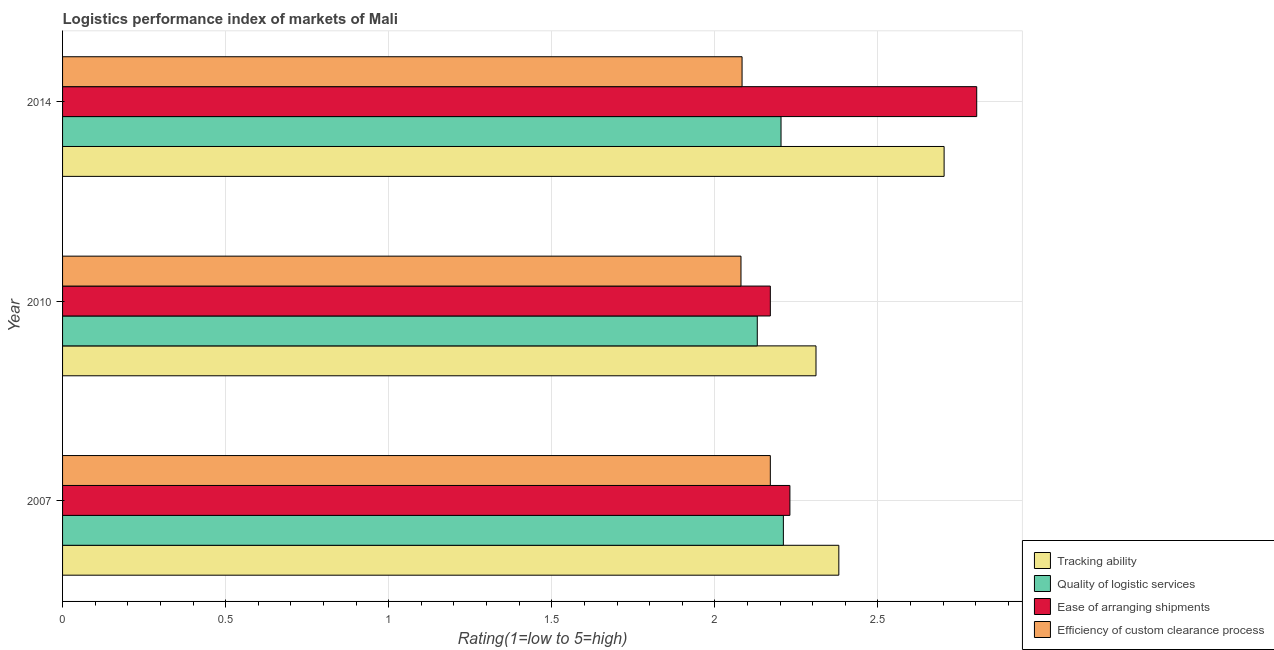How many different coloured bars are there?
Your answer should be compact. 4. How many groups of bars are there?
Offer a terse response. 3. How many bars are there on the 2nd tick from the bottom?
Keep it short and to the point. 4. In how many cases, is the number of bars for a given year not equal to the number of legend labels?
Offer a very short reply. 0. What is the lpi rating of quality of logistic services in 2010?
Your response must be concise. 2.13. Across all years, what is the maximum lpi rating of ease of arranging shipments?
Your answer should be compact. 2.8. Across all years, what is the minimum lpi rating of quality of logistic services?
Provide a succinct answer. 2.13. What is the total lpi rating of ease of arranging shipments in the graph?
Your answer should be compact. 7.2. What is the difference between the lpi rating of quality of logistic services in 2010 and that in 2014?
Provide a short and direct response. -0.07. What is the difference between the lpi rating of ease of arranging shipments in 2010 and the lpi rating of efficiency of custom clearance process in 2007?
Keep it short and to the point. 0. What is the average lpi rating of ease of arranging shipments per year?
Your answer should be compact. 2.4. In the year 2010, what is the difference between the lpi rating of efficiency of custom clearance process and lpi rating of tracking ability?
Offer a terse response. -0.23. In how many years, is the lpi rating of tracking ability greater than 1.7 ?
Your answer should be very brief. 3. What is the ratio of the lpi rating of ease of arranging shipments in 2007 to that in 2010?
Ensure brevity in your answer.  1.03. Is the lpi rating of efficiency of custom clearance process in 2007 less than that in 2014?
Offer a very short reply. No. What is the difference between the highest and the second highest lpi rating of tracking ability?
Your answer should be compact. 0.32. What is the difference between the highest and the lowest lpi rating of efficiency of custom clearance process?
Give a very brief answer. 0.09. In how many years, is the lpi rating of tracking ability greater than the average lpi rating of tracking ability taken over all years?
Ensure brevity in your answer.  1. Is the sum of the lpi rating of ease of arranging shipments in 2010 and 2014 greater than the maximum lpi rating of tracking ability across all years?
Offer a terse response. Yes. What does the 4th bar from the top in 2007 represents?
Give a very brief answer. Tracking ability. What does the 1st bar from the bottom in 2010 represents?
Your answer should be compact. Tracking ability. Is it the case that in every year, the sum of the lpi rating of tracking ability and lpi rating of quality of logistic services is greater than the lpi rating of ease of arranging shipments?
Your answer should be very brief. Yes. How many bars are there?
Provide a short and direct response. 12. Does the graph contain any zero values?
Keep it short and to the point. No. Does the graph contain grids?
Your response must be concise. Yes. Where does the legend appear in the graph?
Ensure brevity in your answer.  Bottom right. How many legend labels are there?
Make the answer very short. 4. What is the title of the graph?
Your answer should be compact. Logistics performance index of markets of Mali. Does "Agriculture" appear as one of the legend labels in the graph?
Offer a very short reply. No. What is the label or title of the X-axis?
Your answer should be compact. Rating(1=low to 5=high). What is the Rating(1=low to 5=high) in Tracking ability in 2007?
Offer a very short reply. 2.38. What is the Rating(1=low to 5=high) of Quality of logistic services in 2007?
Provide a short and direct response. 2.21. What is the Rating(1=low to 5=high) of Ease of arranging shipments in 2007?
Provide a short and direct response. 2.23. What is the Rating(1=low to 5=high) in Efficiency of custom clearance process in 2007?
Provide a short and direct response. 2.17. What is the Rating(1=low to 5=high) in Tracking ability in 2010?
Give a very brief answer. 2.31. What is the Rating(1=low to 5=high) of Quality of logistic services in 2010?
Provide a succinct answer. 2.13. What is the Rating(1=low to 5=high) in Ease of arranging shipments in 2010?
Ensure brevity in your answer.  2.17. What is the Rating(1=low to 5=high) of Efficiency of custom clearance process in 2010?
Make the answer very short. 2.08. What is the Rating(1=low to 5=high) of Tracking ability in 2014?
Your answer should be very brief. 2.7. What is the Rating(1=low to 5=high) of Quality of logistic services in 2014?
Ensure brevity in your answer.  2.2. What is the Rating(1=low to 5=high) of Ease of arranging shipments in 2014?
Your answer should be very brief. 2.8. What is the Rating(1=low to 5=high) of Efficiency of custom clearance process in 2014?
Offer a very short reply. 2.08. Across all years, what is the maximum Rating(1=low to 5=high) in Tracking ability?
Give a very brief answer. 2.7. Across all years, what is the maximum Rating(1=low to 5=high) in Quality of logistic services?
Your answer should be compact. 2.21. Across all years, what is the maximum Rating(1=low to 5=high) of Ease of arranging shipments?
Your answer should be compact. 2.8. Across all years, what is the maximum Rating(1=low to 5=high) in Efficiency of custom clearance process?
Your answer should be very brief. 2.17. Across all years, what is the minimum Rating(1=low to 5=high) in Tracking ability?
Your answer should be compact. 2.31. Across all years, what is the minimum Rating(1=low to 5=high) of Quality of logistic services?
Your response must be concise. 2.13. Across all years, what is the minimum Rating(1=low to 5=high) of Ease of arranging shipments?
Give a very brief answer. 2.17. Across all years, what is the minimum Rating(1=low to 5=high) in Efficiency of custom clearance process?
Provide a succinct answer. 2.08. What is the total Rating(1=low to 5=high) in Tracking ability in the graph?
Provide a succinct answer. 7.39. What is the total Rating(1=low to 5=high) of Quality of logistic services in the graph?
Ensure brevity in your answer.  6.54. What is the total Rating(1=low to 5=high) in Ease of arranging shipments in the graph?
Your answer should be compact. 7.2. What is the total Rating(1=low to 5=high) of Efficiency of custom clearance process in the graph?
Make the answer very short. 6.33. What is the difference between the Rating(1=low to 5=high) of Tracking ability in 2007 and that in 2010?
Give a very brief answer. 0.07. What is the difference between the Rating(1=low to 5=high) in Quality of logistic services in 2007 and that in 2010?
Give a very brief answer. 0.08. What is the difference between the Rating(1=low to 5=high) of Efficiency of custom clearance process in 2007 and that in 2010?
Your response must be concise. 0.09. What is the difference between the Rating(1=low to 5=high) in Tracking ability in 2007 and that in 2014?
Keep it short and to the point. -0.32. What is the difference between the Rating(1=low to 5=high) of Quality of logistic services in 2007 and that in 2014?
Provide a succinct answer. 0.01. What is the difference between the Rating(1=low to 5=high) of Ease of arranging shipments in 2007 and that in 2014?
Offer a very short reply. -0.57. What is the difference between the Rating(1=low to 5=high) in Efficiency of custom clearance process in 2007 and that in 2014?
Provide a succinct answer. 0.09. What is the difference between the Rating(1=low to 5=high) in Tracking ability in 2010 and that in 2014?
Offer a very short reply. -0.39. What is the difference between the Rating(1=low to 5=high) of Quality of logistic services in 2010 and that in 2014?
Offer a terse response. -0.07. What is the difference between the Rating(1=low to 5=high) of Ease of arranging shipments in 2010 and that in 2014?
Provide a succinct answer. -0.63. What is the difference between the Rating(1=low to 5=high) in Efficiency of custom clearance process in 2010 and that in 2014?
Offer a very short reply. -0. What is the difference between the Rating(1=low to 5=high) of Tracking ability in 2007 and the Rating(1=low to 5=high) of Quality of logistic services in 2010?
Your answer should be compact. 0.25. What is the difference between the Rating(1=low to 5=high) in Tracking ability in 2007 and the Rating(1=low to 5=high) in Ease of arranging shipments in 2010?
Your answer should be very brief. 0.21. What is the difference between the Rating(1=low to 5=high) of Tracking ability in 2007 and the Rating(1=low to 5=high) of Efficiency of custom clearance process in 2010?
Offer a very short reply. 0.3. What is the difference between the Rating(1=low to 5=high) in Quality of logistic services in 2007 and the Rating(1=low to 5=high) in Efficiency of custom clearance process in 2010?
Offer a terse response. 0.13. What is the difference between the Rating(1=low to 5=high) in Tracking ability in 2007 and the Rating(1=low to 5=high) in Quality of logistic services in 2014?
Offer a terse response. 0.18. What is the difference between the Rating(1=low to 5=high) of Tracking ability in 2007 and the Rating(1=low to 5=high) of Ease of arranging shipments in 2014?
Make the answer very short. -0.42. What is the difference between the Rating(1=low to 5=high) of Tracking ability in 2007 and the Rating(1=low to 5=high) of Efficiency of custom clearance process in 2014?
Ensure brevity in your answer.  0.3. What is the difference between the Rating(1=low to 5=high) of Quality of logistic services in 2007 and the Rating(1=low to 5=high) of Ease of arranging shipments in 2014?
Your answer should be compact. -0.59. What is the difference between the Rating(1=low to 5=high) of Quality of logistic services in 2007 and the Rating(1=low to 5=high) of Efficiency of custom clearance process in 2014?
Make the answer very short. 0.13. What is the difference between the Rating(1=low to 5=high) of Ease of arranging shipments in 2007 and the Rating(1=low to 5=high) of Efficiency of custom clearance process in 2014?
Your answer should be very brief. 0.15. What is the difference between the Rating(1=low to 5=high) in Tracking ability in 2010 and the Rating(1=low to 5=high) in Quality of logistic services in 2014?
Provide a succinct answer. 0.11. What is the difference between the Rating(1=low to 5=high) in Tracking ability in 2010 and the Rating(1=low to 5=high) in Ease of arranging shipments in 2014?
Provide a succinct answer. -0.49. What is the difference between the Rating(1=low to 5=high) of Tracking ability in 2010 and the Rating(1=low to 5=high) of Efficiency of custom clearance process in 2014?
Make the answer very short. 0.23. What is the difference between the Rating(1=low to 5=high) in Quality of logistic services in 2010 and the Rating(1=low to 5=high) in Ease of arranging shipments in 2014?
Your response must be concise. -0.67. What is the difference between the Rating(1=low to 5=high) in Quality of logistic services in 2010 and the Rating(1=low to 5=high) in Efficiency of custom clearance process in 2014?
Your answer should be very brief. 0.05. What is the difference between the Rating(1=low to 5=high) of Ease of arranging shipments in 2010 and the Rating(1=low to 5=high) of Efficiency of custom clearance process in 2014?
Keep it short and to the point. 0.09. What is the average Rating(1=low to 5=high) of Tracking ability per year?
Your answer should be very brief. 2.46. What is the average Rating(1=low to 5=high) in Quality of logistic services per year?
Provide a short and direct response. 2.18. What is the average Rating(1=low to 5=high) in Ease of arranging shipments per year?
Keep it short and to the point. 2.4. What is the average Rating(1=low to 5=high) in Efficiency of custom clearance process per year?
Make the answer very short. 2.11. In the year 2007, what is the difference between the Rating(1=low to 5=high) of Tracking ability and Rating(1=low to 5=high) of Quality of logistic services?
Provide a succinct answer. 0.17. In the year 2007, what is the difference between the Rating(1=low to 5=high) of Tracking ability and Rating(1=low to 5=high) of Efficiency of custom clearance process?
Give a very brief answer. 0.21. In the year 2007, what is the difference between the Rating(1=low to 5=high) of Quality of logistic services and Rating(1=low to 5=high) of Ease of arranging shipments?
Offer a very short reply. -0.02. In the year 2007, what is the difference between the Rating(1=low to 5=high) of Quality of logistic services and Rating(1=low to 5=high) of Efficiency of custom clearance process?
Offer a terse response. 0.04. In the year 2007, what is the difference between the Rating(1=low to 5=high) of Ease of arranging shipments and Rating(1=low to 5=high) of Efficiency of custom clearance process?
Your response must be concise. 0.06. In the year 2010, what is the difference between the Rating(1=low to 5=high) in Tracking ability and Rating(1=low to 5=high) in Quality of logistic services?
Keep it short and to the point. 0.18. In the year 2010, what is the difference between the Rating(1=low to 5=high) in Tracking ability and Rating(1=low to 5=high) in Ease of arranging shipments?
Ensure brevity in your answer.  0.14. In the year 2010, what is the difference between the Rating(1=low to 5=high) of Tracking ability and Rating(1=low to 5=high) of Efficiency of custom clearance process?
Provide a succinct answer. 0.23. In the year 2010, what is the difference between the Rating(1=low to 5=high) of Quality of logistic services and Rating(1=low to 5=high) of Ease of arranging shipments?
Your answer should be very brief. -0.04. In the year 2010, what is the difference between the Rating(1=low to 5=high) of Ease of arranging shipments and Rating(1=low to 5=high) of Efficiency of custom clearance process?
Provide a succinct answer. 0.09. In the year 2014, what is the difference between the Rating(1=low to 5=high) in Tracking ability and Rating(1=low to 5=high) in Ease of arranging shipments?
Provide a succinct answer. -0.1. In the year 2014, what is the difference between the Rating(1=low to 5=high) in Tracking ability and Rating(1=low to 5=high) in Efficiency of custom clearance process?
Offer a very short reply. 0.62. In the year 2014, what is the difference between the Rating(1=low to 5=high) in Quality of logistic services and Rating(1=low to 5=high) in Efficiency of custom clearance process?
Provide a succinct answer. 0.12. In the year 2014, what is the difference between the Rating(1=low to 5=high) in Ease of arranging shipments and Rating(1=low to 5=high) in Efficiency of custom clearance process?
Your answer should be very brief. 0.72. What is the ratio of the Rating(1=low to 5=high) of Tracking ability in 2007 to that in 2010?
Your answer should be very brief. 1.03. What is the ratio of the Rating(1=low to 5=high) in Quality of logistic services in 2007 to that in 2010?
Make the answer very short. 1.04. What is the ratio of the Rating(1=low to 5=high) in Ease of arranging shipments in 2007 to that in 2010?
Your answer should be compact. 1.03. What is the ratio of the Rating(1=low to 5=high) in Efficiency of custom clearance process in 2007 to that in 2010?
Offer a very short reply. 1.04. What is the ratio of the Rating(1=low to 5=high) of Tracking ability in 2007 to that in 2014?
Your response must be concise. 0.88. What is the ratio of the Rating(1=low to 5=high) in Ease of arranging shipments in 2007 to that in 2014?
Make the answer very short. 0.8. What is the ratio of the Rating(1=low to 5=high) in Efficiency of custom clearance process in 2007 to that in 2014?
Provide a succinct answer. 1.04. What is the ratio of the Rating(1=low to 5=high) in Tracking ability in 2010 to that in 2014?
Give a very brief answer. 0.85. What is the ratio of the Rating(1=low to 5=high) in Ease of arranging shipments in 2010 to that in 2014?
Your answer should be very brief. 0.77. What is the difference between the highest and the second highest Rating(1=low to 5=high) in Tracking ability?
Give a very brief answer. 0.32. What is the difference between the highest and the second highest Rating(1=low to 5=high) in Quality of logistic services?
Offer a terse response. 0.01. What is the difference between the highest and the second highest Rating(1=low to 5=high) in Ease of arranging shipments?
Provide a short and direct response. 0.57. What is the difference between the highest and the second highest Rating(1=low to 5=high) in Efficiency of custom clearance process?
Make the answer very short. 0.09. What is the difference between the highest and the lowest Rating(1=low to 5=high) of Tracking ability?
Make the answer very short. 0.39. What is the difference between the highest and the lowest Rating(1=low to 5=high) in Quality of logistic services?
Ensure brevity in your answer.  0.08. What is the difference between the highest and the lowest Rating(1=low to 5=high) of Ease of arranging shipments?
Provide a succinct answer. 0.63. What is the difference between the highest and the lowest Rating(1=low to 5=high) of Efficiency of custom clearance process?
Offer a terse response. 0.09. 